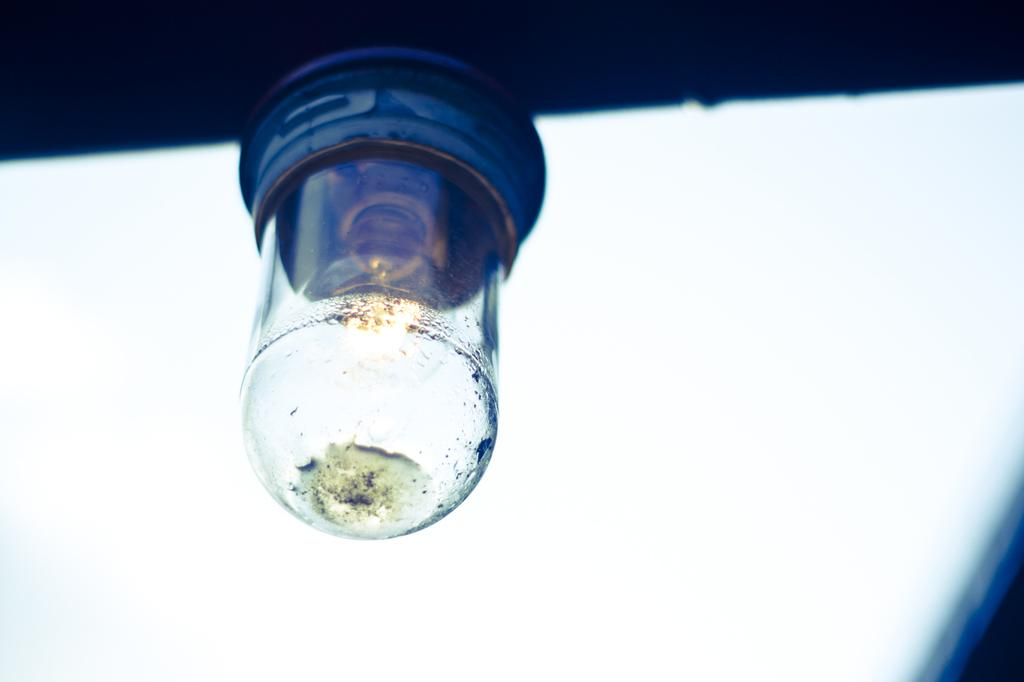What object is the main focus of the image? There is a bulb in the image. What color is the background of the image? The background of the image is white. How many members are in the band that is performing in the image? There is no band present in the image; it only features a bulb. What type of relationship do the brothers have in the image? There are no brothers present in the image; it only features a bulb. 